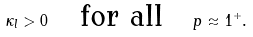<formula> <loc_0><loc_0><loc_500><loc_500>\kappa _ { l } > 0 \quad \text {for all} \quad p \approx 1 ^ { + } .</formula> 